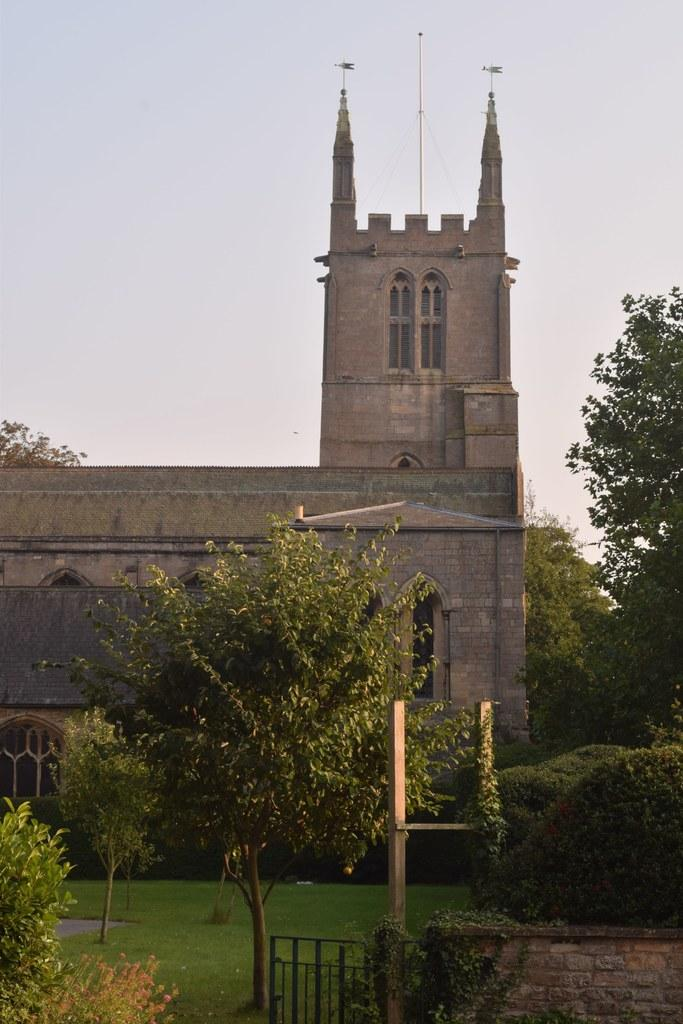What type of structure is present in the image? There is a building in the image. What feature can be seen on the building? The building has windows. What type of vegetation is visible in the image? There are trees in the image. What part of the natural environment is visible in the image? The sky is visible in the image. Can you see a family using a slip and knife in the image? There is no family, slip, or knife present in the image. 